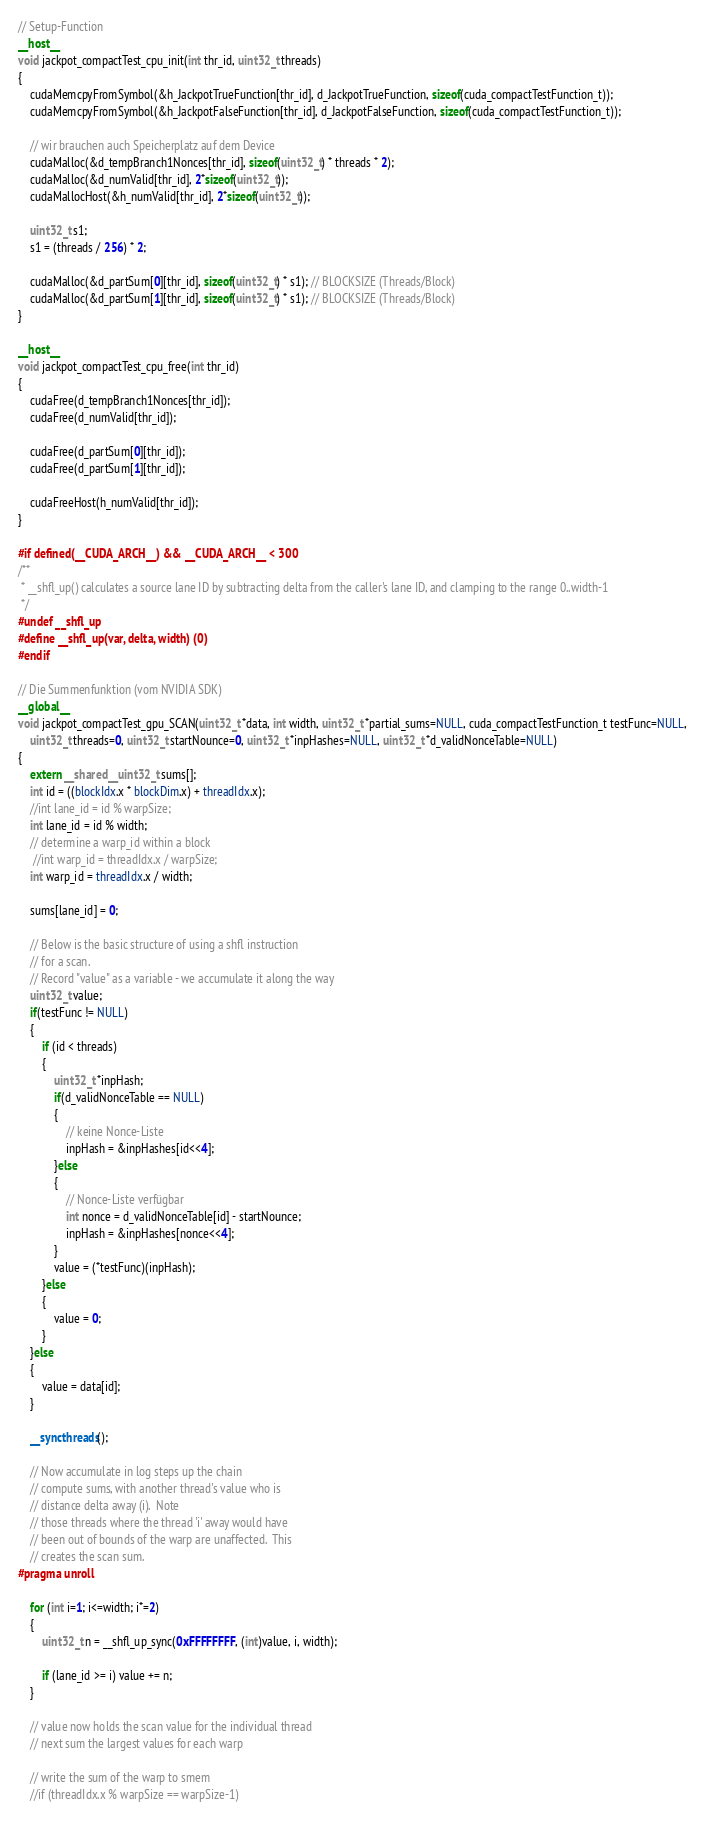Convert code to text. <code><loc_0><loc_0><loc_500><loc_500><_Cuda_>
// Setup-Function
__host__
void jackpot_compactTest_cpu_init(int thr_id, uint32_t threads)
{
	cudaMemcpyFromSymbol(&h_JackpotTrueFunction[thr_id], d_JackpotTrueFunction, sizeof(cuda_compactTestFunction_t));
	cudaMemcpyFromSymbol(&h_JackpotFalseFunction[thr_id], d_JackpotFalseFunction, sizeof(cuda_compactTestFunction_t));

	// wir brauchen auch Speicherplatz auf dem Device
	cudaMalloc(&d_tempBranch1Nonces[thr_id], sizeof(uint32_t) * threads * 2);	
	cudaMalloc(&d_numValid[thr_id], 2*sizeof(uint32_t));
	cudaMallocHost(&h_numValid[thr_id], 2*sizeof(uint32_t));

	uint32_t s1;
	s1 = (threads / 256) * 2;

	cudaMalloc(&d_partSum[0][thr_id], sizeof(uint32_t) * s1); // BLOCKSIZE (Threads/Block)
	cudaMalloc(&d_partSum[1][thr_id], sizeof(uint32_t) * s1); // BLOCKSIZE (Threads/Block)
}

__host__
void jackpot_compactTest_cpu_free(int thr_id)
{
	cudaFree(d_tempBranch1Nonces[thr_id]);
	cudaFree(d_numValid[thr_id]);

	cudaFree(d_partSum[0][thr_id]);
	cudaFree(d_partSum[1][thr_id]);

	cudaFreeHost(h_numValid[thr_id]);
}

#if defined(__CUDA_ARCH__) && __CUDA_ARCH__ < 300
/**
 * __shfl_up() calculates a source lane ID by subtracting delta from the caller's lane ID, and clamping to the range 0..width-1
 */
#undef __shfl_up
#define __shfl_up(var, delta, width) (0)
#endif

// Die Summenfunktion (vom NVIDIA SDK)
__global__
void jackpot_compactTest_gpu_SCAN(uint32_t *data, int width, uint32_t *partial_sums=NULL, cuda_compactTestFunction_t testFunc=NULL,
	uint32_t threads=0, uint32_t startNounce=0, uint32_t *inpHashes=NULL, uint32_t *d_validNonceTable=NULL)
{
	extern __shared__ uint32_t sums[];
	int id = ((blockIdx.x * blockDim.x) + threadIdx.x);
	//int lane_id = id % warpSize;
	int lane_id = id % width;
	// determine a warp_id within a block
	 //int warp_id = threadIdx.x / warpSize;
	int warp_id = threadIdx.x / width;

	sums[lane_id] = 0;

	// Below is the basic structure of using a shfl instruction
	// for a scan.
	// Record "value" as a variable - we accumulate it along the way
	uint32_t value;
	if(testFunc != NULL)
	{
		if (id < threads)
		{
			uint32_t *inpHash;
			if(d_validNonceTable == NULL)
			{
				// keine Nonce-Liste
				inpHash = &inpHashes[id<<4];
			}else
			{
				// Nonce-Liste verfügbar
				int nonce = d_validNonceTable[id] - startNounce;
				inpHash = &inpHashes[nonce<<4];
			}			
			value = (*testFunc)(inpHash);
		}else
		{
			value = 0;
		}
	}else
	{
		value = data[id];
	}

	__syncthreads();

	// Now accumulate in log steps up the chain
	// compute sums, with another thread's value who is
	// distance delta away (i).  Note
	// those threads where the thread 'i' away would have
	// been out of bounds of the warp are unaffected.  This
	// creates the scan sum.
#pragma unroll

	for (int i=1; i<=width; i*=2)
	{
		uint32_t n = __shfl_up_sync(0xFFFFFFFF, (int)value, i, width);

		if (lane_id >= i) value += n;
	}

	// value now holds the scan value for the individual thread
	// next sum the largest values for each warp

	// write the sum of the warp to smem
	//if (threadIdx.x % warpSize == warpSize-1)</code> 